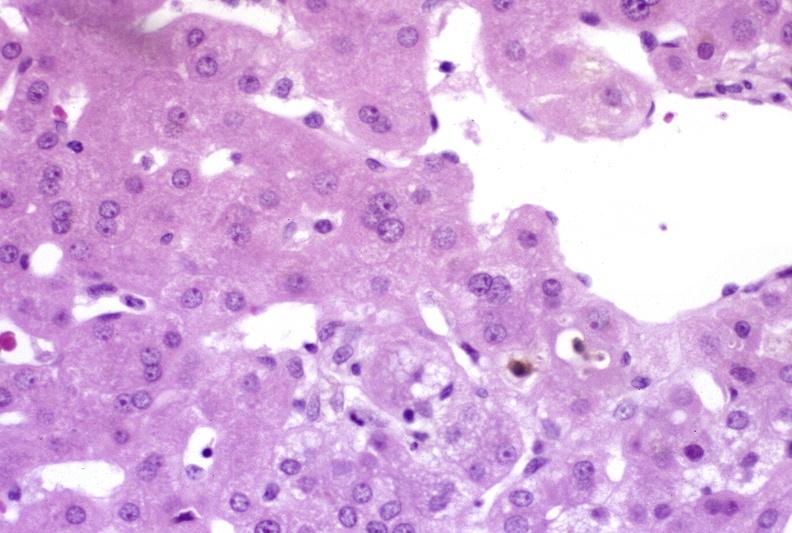s hemorrhagic corpus luteum present?
Answer the question using a single word or phrase. No 